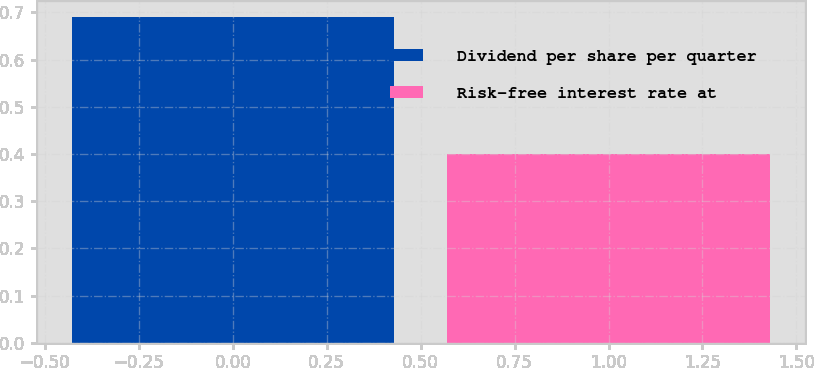Convert chart to OTSL. <chart><loc_0><loc_0><loc_500><loc_500><bar_chart><fcel>Dividend per share per quarter<fcel>Risk-free interest rate at<nl><fcel>0.69<fcel>0.4<nl></chart> 